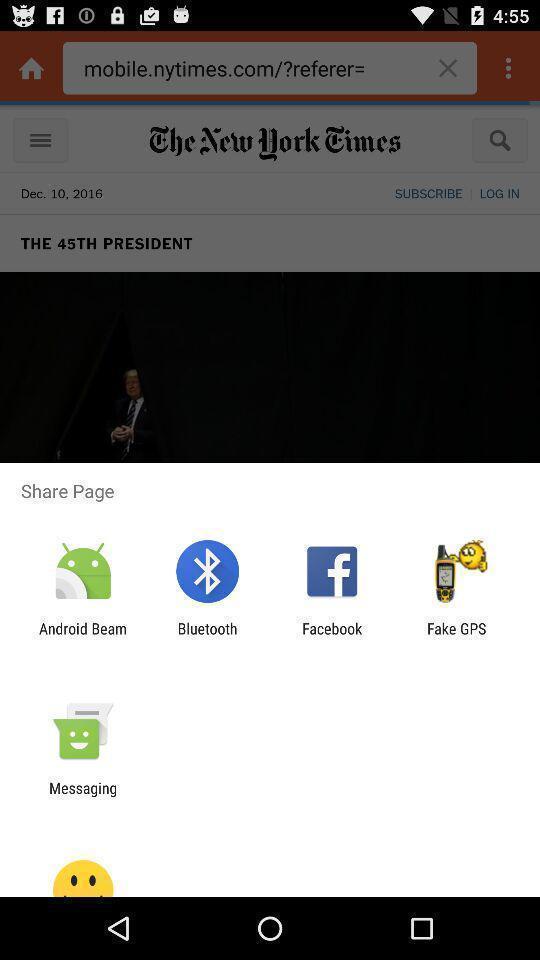Please provide a description for this image. Pop-up showing different share options. 